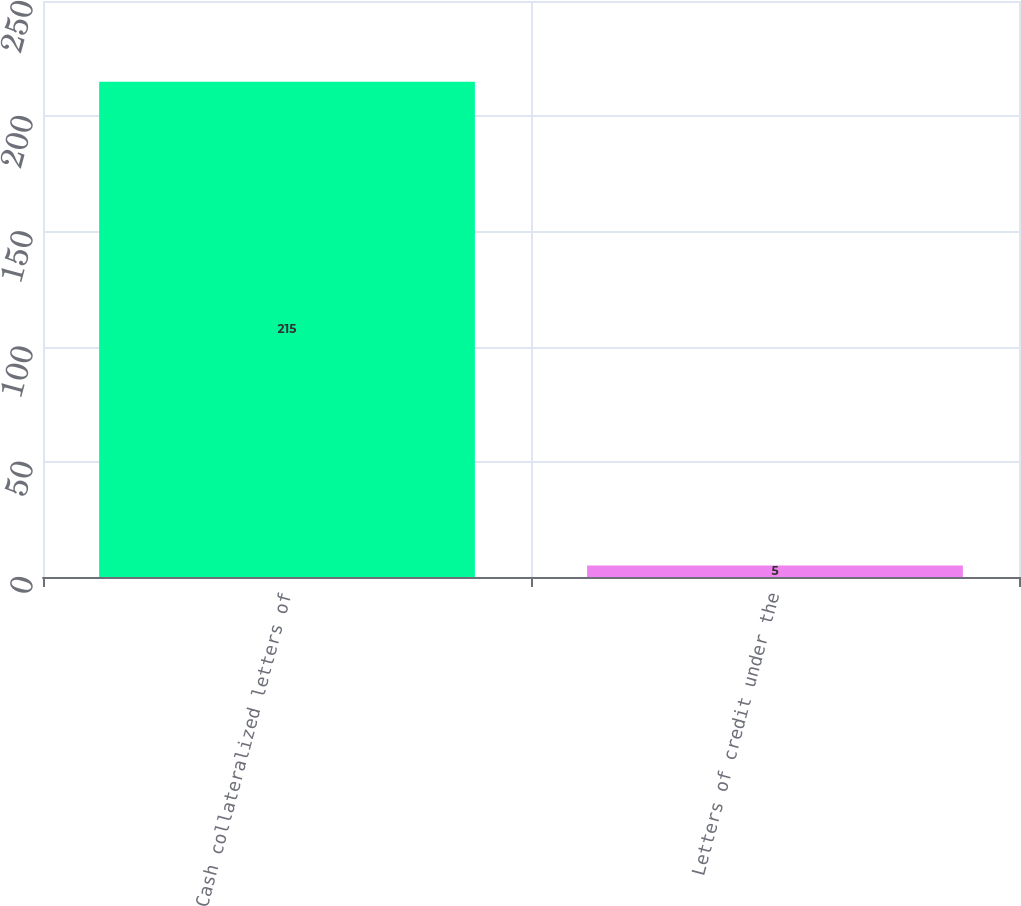Convert chart. <chart><loc_0><loc_0><loc_500><loc_500><bar_chart><fcel>Cash collateralized letters of<fcel>Letters of credit under the<nl><fcel>215<fcel>5<nl></chart> 